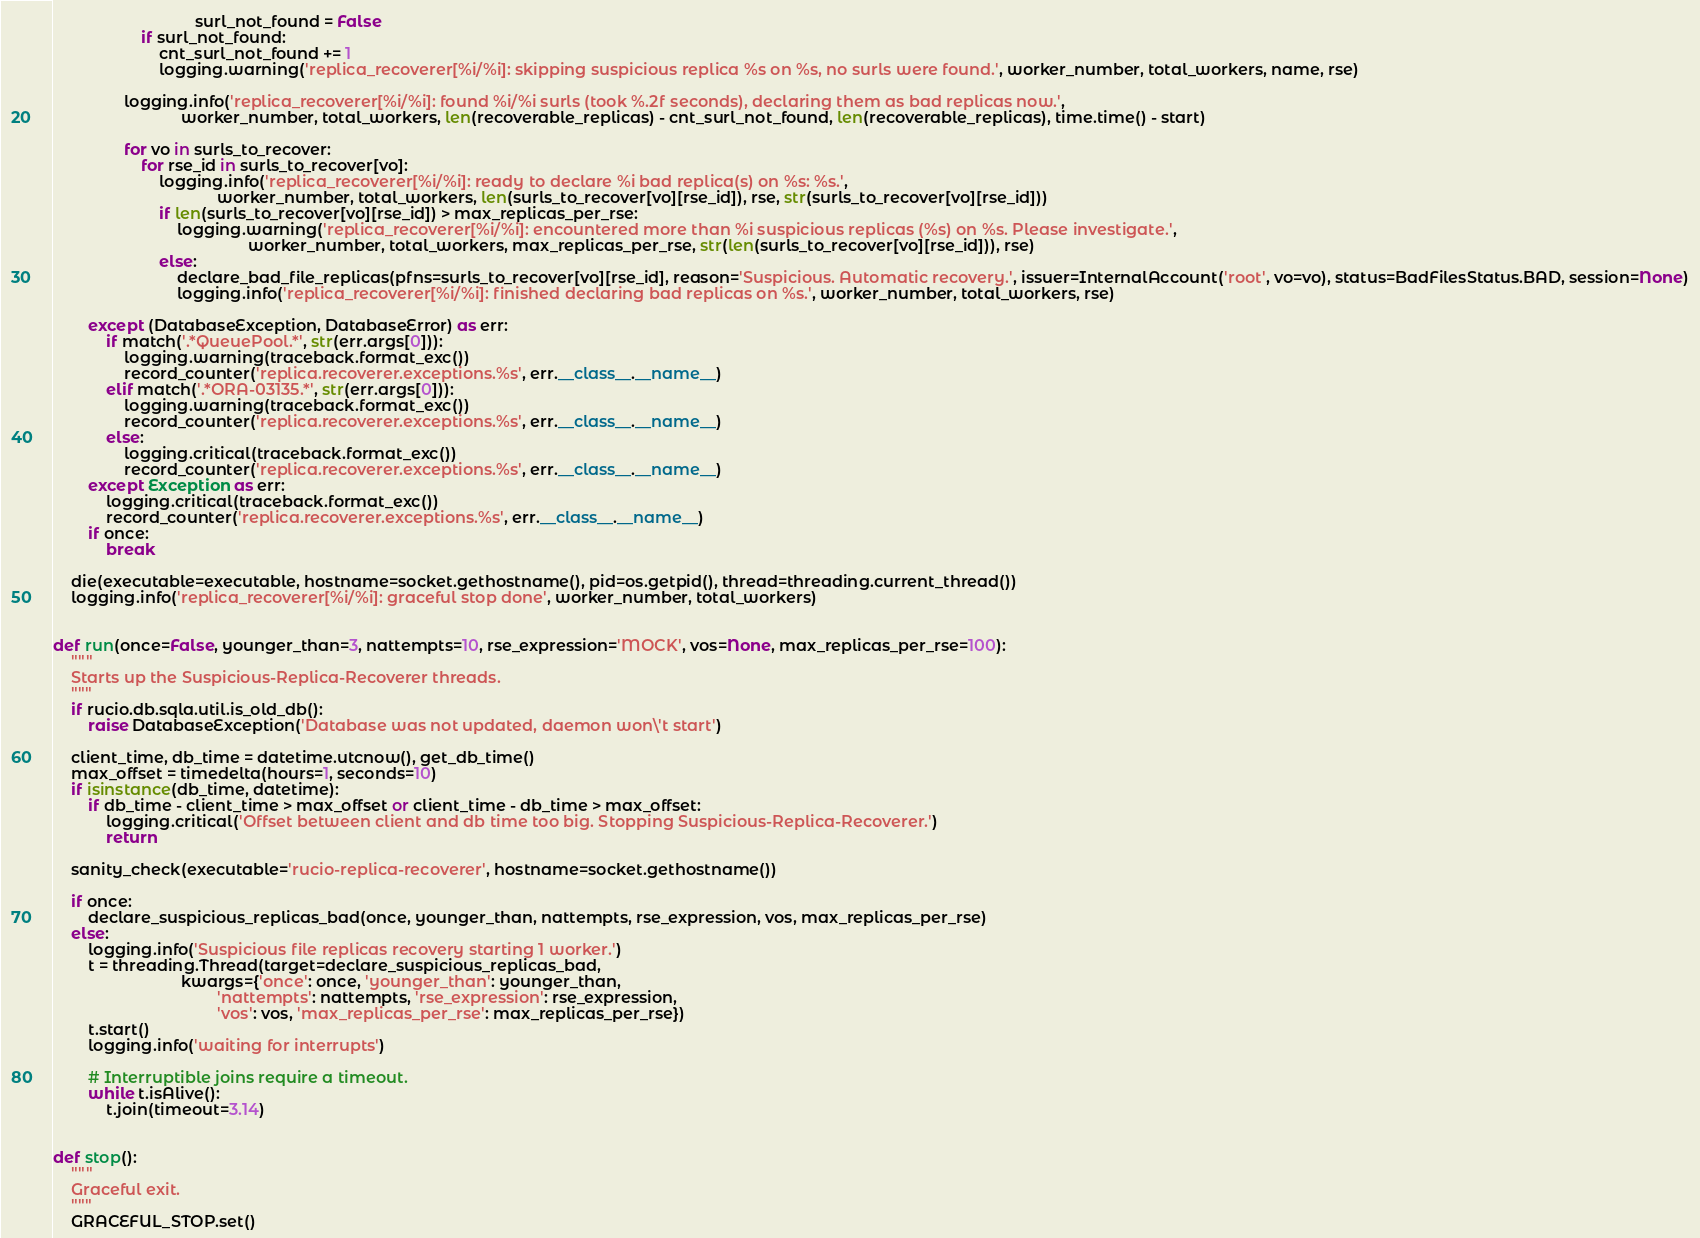Convert code to text. <code><loc_0><loc_0><loc_500><loc_500><_Python_>                                surl_not_found = False
                    if surl_not_found:
                        cnt_surl_not_found += 1
                        logging.warning('replica_recoverer[%i/%i]: skipping suspicious replica %s on %s, no surls were found.', worker_number, total_workers, name, rse)

                logging.info('replica_recoverer[%i/%i]: found %i/%i surls (took %.2f seconds), declaring them as bad replicas now.',
                             worker_number, total_workers, len(recoverable_replicas) - cnt_surl_not_found, len(recoverable_replicas), time.time() - start)

                for vo in surls_to_recover:
                    for rse_id in surls_to_recover[vo]:
                        logging.info('replica_recoverer[%i/%i]: ready to declare %i bad replica(s) on %s: %s.',
                                     worker_number, total_workers, len(surls_to_recover[vo][rse_id]), rse, str(surls_to_recover[vo][rse_id]))
                        if len(surls_to_recover[vo][rse_id]) > max_replicas_per_rse:
                            logging.warning('replica_recoverer[%i/%i]: encountered more than %i suspicious replicas (%s) on %s. Please investigate.',
                                            worker_number, total_workers, max_replicas_per_rse, str(len(surls_to_recover[vo][rse_id])), rse)
                        else:
                            declare_bad_file_replicas(pfns=surls_to_recover[vo][rse_id], reason='Suspicious. Automatic recovery.', issuer=InternalAccount('root', vo=vo), status=BadFilesStatus.BAD, session=None)
                            logging.info('replica_recoverer[%i/%i]: finished declaring bad replicas on %s.', worker_number, total_workers, rse)

        except (DatabaseException, DatabaseError) as err:
            if match('.*QueuePool.*', str(err.args[0])):
                logging.warning(traceback.format_exc())
                record_counter('replica.recoverer.exceptions.%s', err.__class__.__name__)
            elif match('.*ORA-03135.*', str(err.args[0])):
                logging.warning(traceback.format_exc())
                record_counter('replica.recoverer.exceptions.%s', err.__class__.__name__)
            else:
                logging.critical(traceback.format_exc())
                record_counter('replica.recoverer.exceptions.%s', err.__class__.__name__)
        except Exception as err:
            logging.critical(traceback.format_exc())
            record_counter('replica.recoverer.exceptions.%s', err.__class__.__name__)
        if once:
            break

    die(executable=executable, hostname=socket.gethostname(), pid=os.getpid(), thread=threading.current_thread())
    logging.info('replica_recoverer[%i/%i]: graceful stop done', worker_number, total_workers)


def run(once=False, younger_than=3, nattempts=10, rse_expression='MOCK', vos=None, max_replicas_per_rse=100):
    """
    Starts up the Suspicious-Replica-Recoverer threads.
    """
    if rucio.db.sqla.util.is_old_db():
        raise DatabaseException('Database was not updated, daemon won\'t start')

    client_time, db_time = datetime.utcnow(), get_db_time()
    max_offset = timedelta(hours=1, seconds=10)
    if isinstance(db_time, datetime):
        if db_time - client_time > max_offset or client_time - db_time > max_offset:
            logging.critical('Offset between client and db time too big. Stopping Suspicious-Replica-Recoverer.')
            return

    sanity_check(executable='rucio-replica-recoverer', hostname=socket.gethostname())

    if once:
        declare_suspicious_replicas_bad(once, younger_than, nattempts, rse_expression, vos, max_replicas_per_rse)
    else:
        logging.info('Suspicious file replicas recovery starting 1 worker.')
        t = threading.Thread(target=declare_suspicious_replicas_bad,
                             kwargs={'once': once, 'younger_than': younger_than,
                                     'nattempts': nattempts, 'rse_expression': rse_expression,
                                     'vos': vos, 'max_replicas_per_rse': max_replicas_per_rse})
        t.start()
        logging.info('waiting for interrupts')

        # Interruptible joins require a timeout.
        while t.isAlive():
            t.join(timeout=3.14)


def stop():
    """
    Graceful exit.
    """
    GRACEFUL_STOP.set()
</code> 